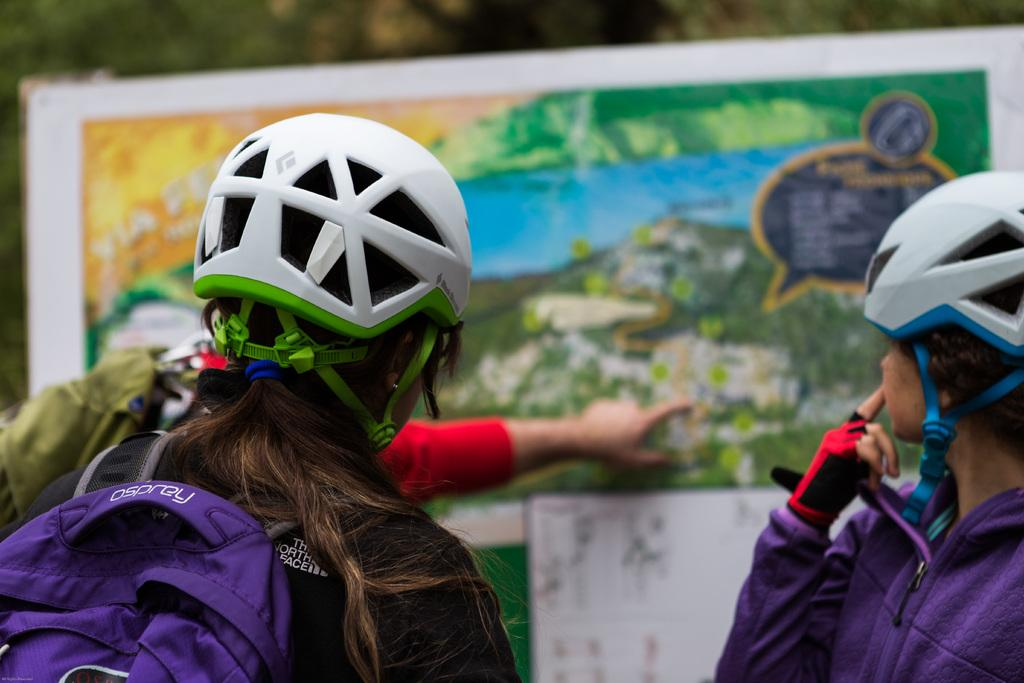How many people are in the image? There are three persons in the image. What can be seen in addition to the people in the image? There is a board visible in the image. What type of silk is draped over the wall in the image? There is no silk or wall present in the image; it only features three persons and a board. 